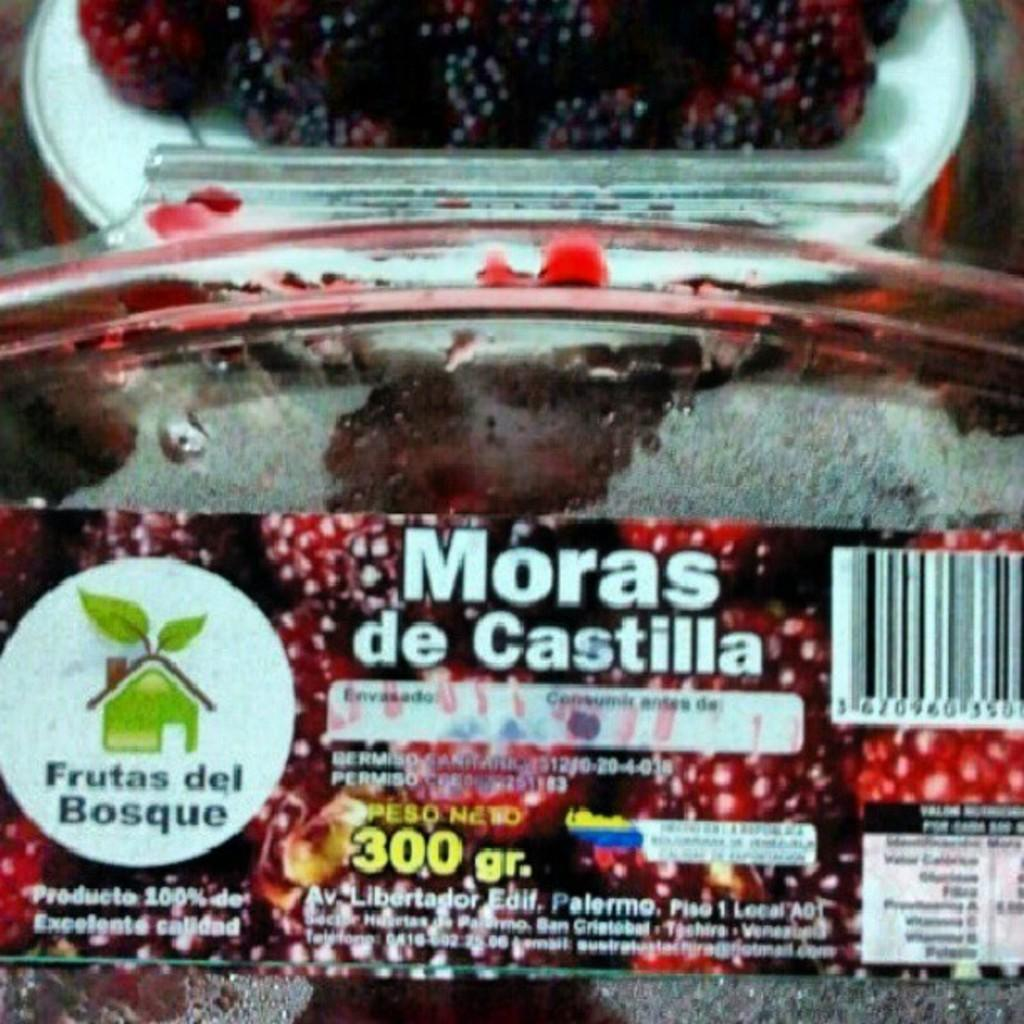What is on the box that can be seen in the image? There are texts written on the box in the image. Where is the box located in the image? The box is on a plate in the image. What type of food is present in the image? There are berries in a plate in the image. How are the berries arranged on the plate? The berries are at the top of the plate. What type of toothpaste is visible in the image? There is no toothpaste present in the image. Can you see any eggnog in the image? There is no eggnog present in the image. 